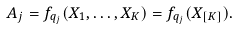<formula> <loc_0><loc_0><loc_500><loc_500>A _ { j } = f _ { q _ { j } } ( X _ { 1 } , \dots , X _ { K } ) = f _ { q _ { j } } ( X _ { [ K ] } ) .</formula> 